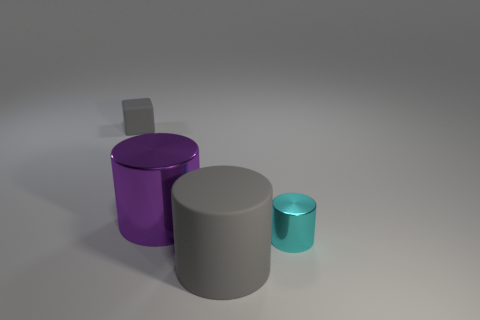Subtract all matte cylinders. How many cylinders are left? 2 Add 3 small yellow cylinders. How many objects exist? 7 Subtract all gray cylinders. How many cylinders are left? 2 Subtract all cubes. How many objects are left? 3 Add 2 large matte cylinders. How many large matte cylinders exist? 3 Subtract 0 green cylinders. How many objects are left? 4 Subtract all purple blocks. Subtract all purple cylinders. How many blocks are left? 1 Subtract all gray cylinders. Subtract all blocks. How many objects are left? 2 Add 4 large gray objects. How many large gray objects are left? 5 